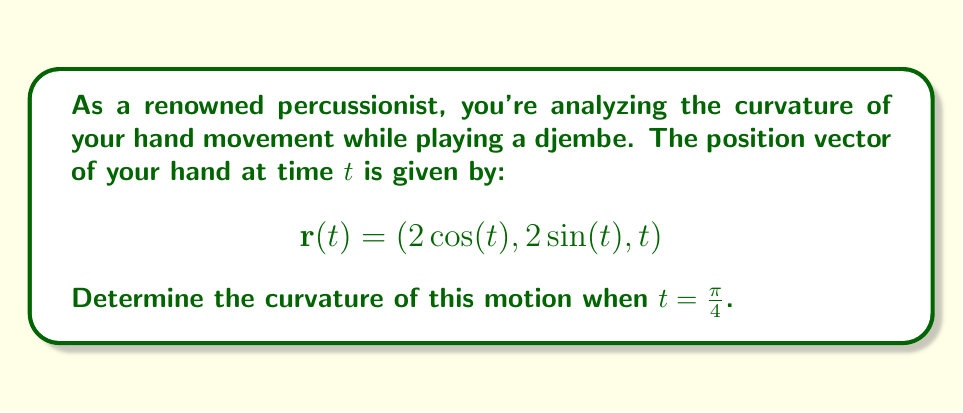Provide a solution to this math problem. To find the curvature of a vector-valued function, we use the formula:

$$\kappa = \frac{|\mathbf{r}'(t) \times \mathbf{r}''(t)|}{|\mathbf{r}'(t)|^3}$$

Let's follow these steps:

1) First, we need to find $\mathbf{r}'(t)$ and $\mathbf{r}''(t)$:

   $$\mathbf{r}'(t) = (-2\sin(t), 2\cos(t), 1)$$
   $$\mathbf{r}''(t) = (-2\cos(t), -2\sin(t), 0)$$

2) Now, let's evaluate these at $t = \frac{\pi}{4}$:

   $$\mathbf{r}'(\frac{\pi}{4}) = (-\sqrt{2}, \sqrt{2}, 1)$$
   $$\mathbf{r}''(\frac{\pi}{4}) = (-\sqrt{2}, -\sqrt{2}, 0)$$

3) Next, we need to calculate the cross product $\mathbf{r}'(\frac{\pi}{4}) \times \mathbf{r}''(\frac{\pi}{4})$:

   $$\begin{vmatrix} 
   \mathbf{i} & \mathbf{j} & \mathbf{k} \\
   -\sqrt{2} & \sqrt{2} & 1 \\
   -\sqrt{2} & -\sqrt{2} & 0
   \end{vmatrix} = (-\sqrt{2})\mathbf{i} + (-\sqrt{2})\mathbf{j} + (-2)\mathbf{k}$$

4) The magnitude of this cross product is:

   $$|\mathbf{r}'(\frac{\pi}{4}) \times \mathbf{r}''(\frac{\pi}{4})| = \sqrt{(-\sqrt{2})^2 + (-\sqrt{2})^2 + (-2)^2} = 2\sqrt{3}$$

5) Now, we need to calculate $|\mathbf{r}'(\frac{\pi}{4})|^3$:

   $$|\mathbf{r}'(\frac{\pi}{4})| = \sqrt{(-\sqrt{2})^2 + (\sqrt{2})^2 + 1^2} = \sqrt{5}$$
   $$|\mathbf{r}'(\frac{\pi}{4})|^3 = (\sqrt{5})^3 = 5\sqrt{5}$$

6) Finally, we can plug these values into our curvature formula:

   $$\kappa = \frac{2\sqrt{3}}{5\sqrt{5}}$$

This can be simplified by rationalizing the denominator:

$$\kappa = \frac{2\sqrt{3}}{5\sqrt{5}} \cdot \frac{\sqrt{5}}{\sqrt{5}} = \frac{2\sqrt{15}}{25}$$
Answer: $$\kappa = \frac{2\sqrt{15}}{25}$$ 